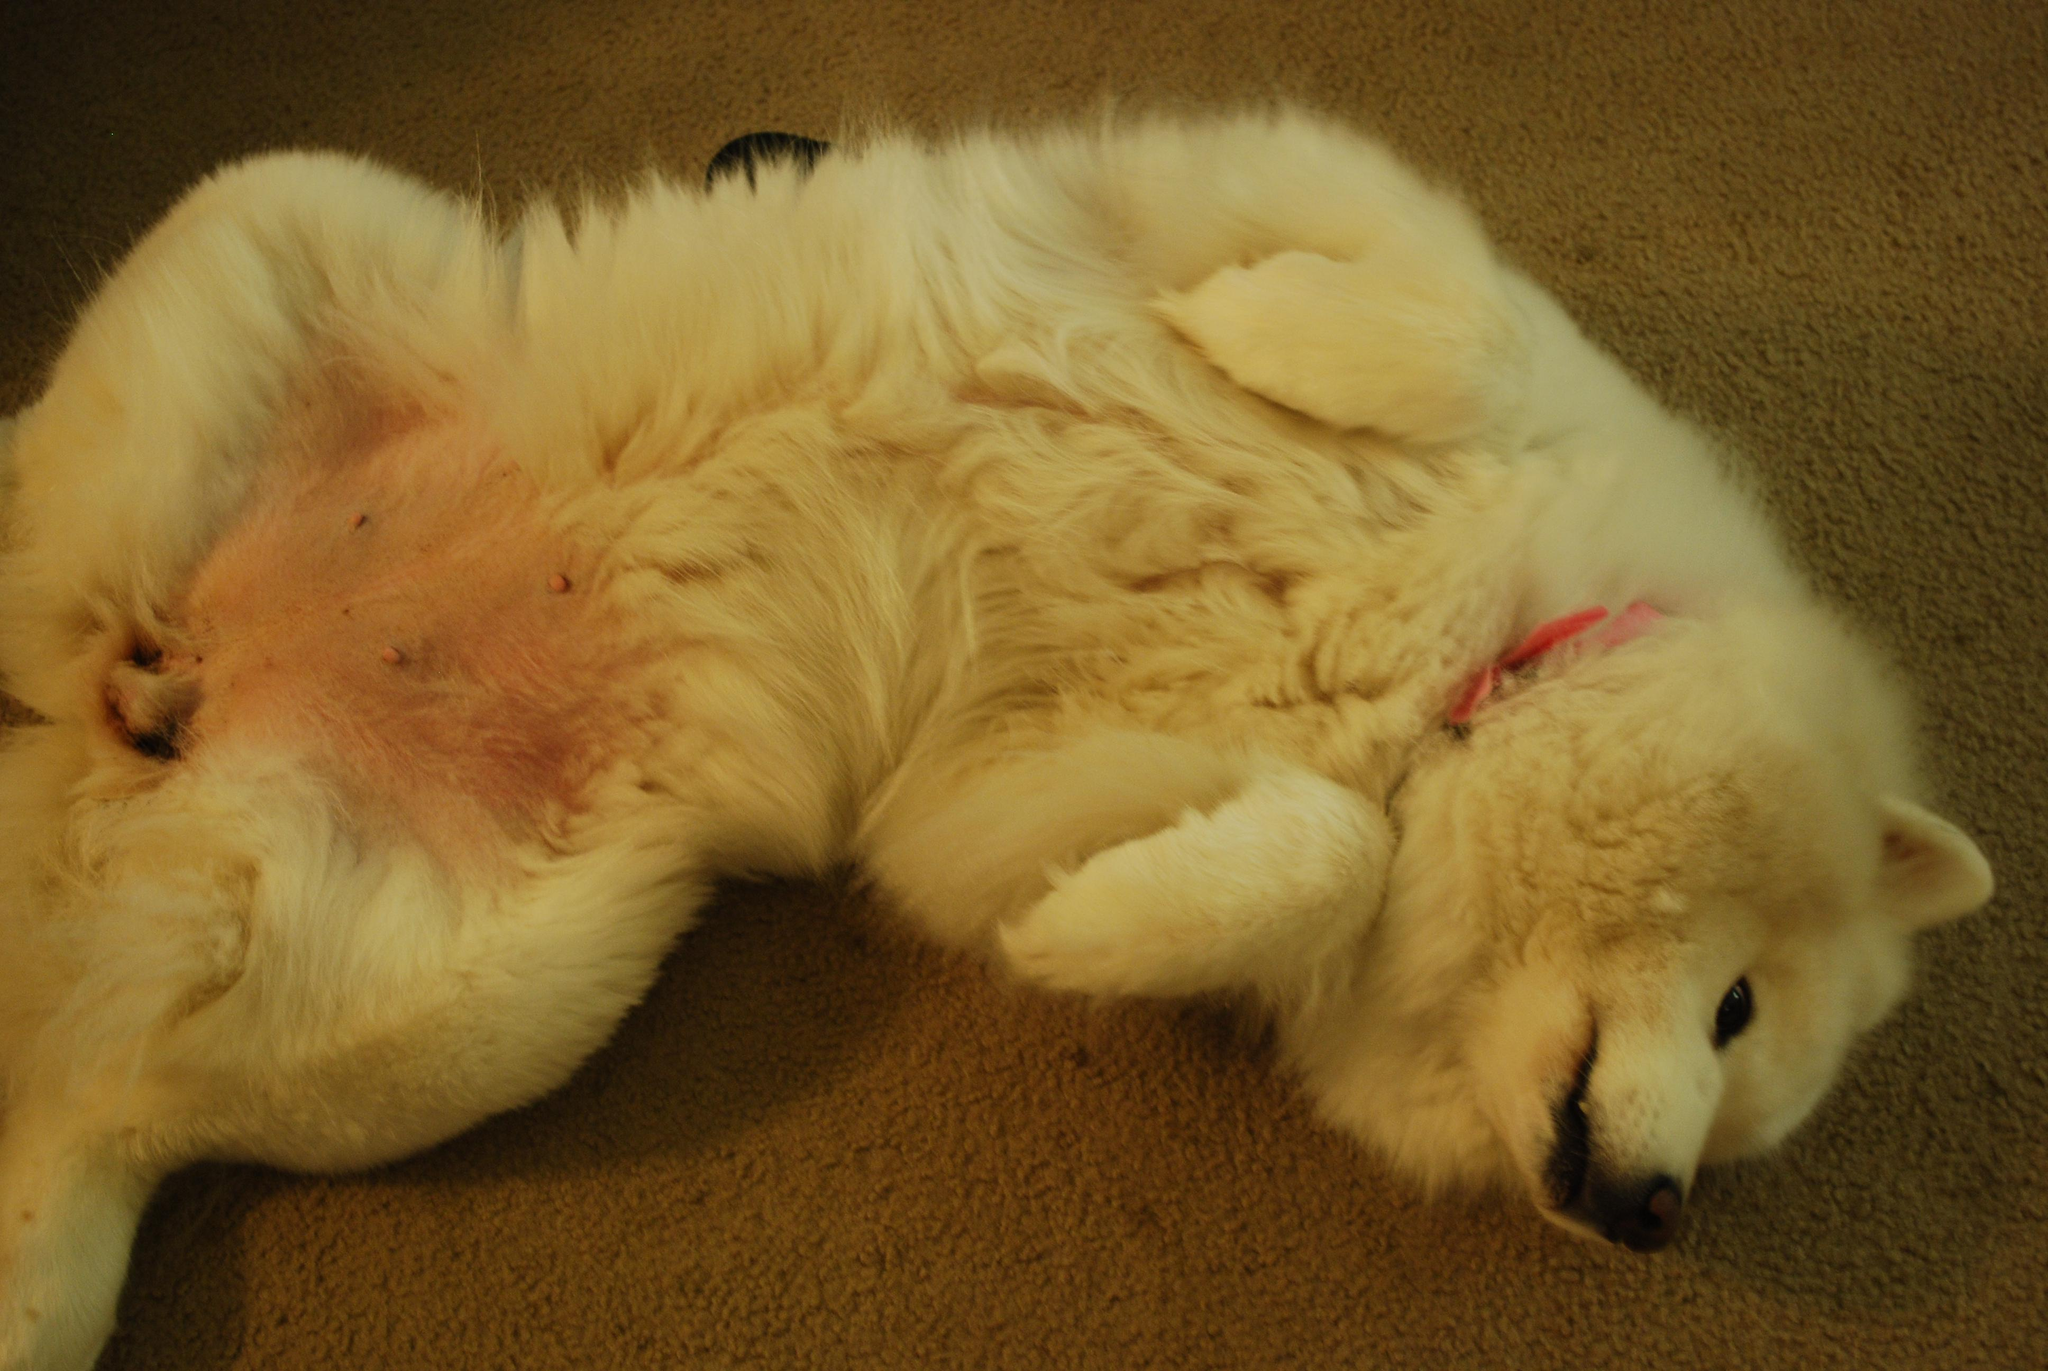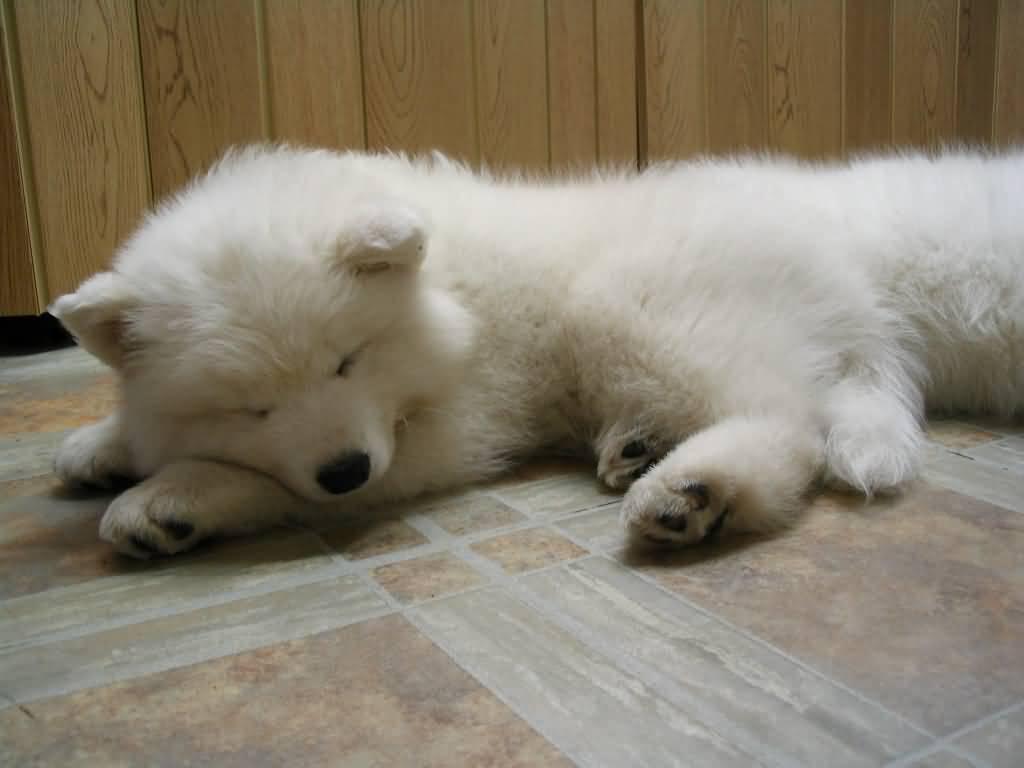The first image is the image on the left, the second image is the image on the right. Evaluate the accuracy of this statement regarding the images: "Right image shows a white dog sleeping on the floor with its belly facing up.". Is it true? Answer yes or no. No. The first image is the image on the left, the second image is the image on the right. Examine the images to the left and right. Is the description "At least one dog in one of the images has its tongue hanging out." accurate? Answer yes or no. No. 